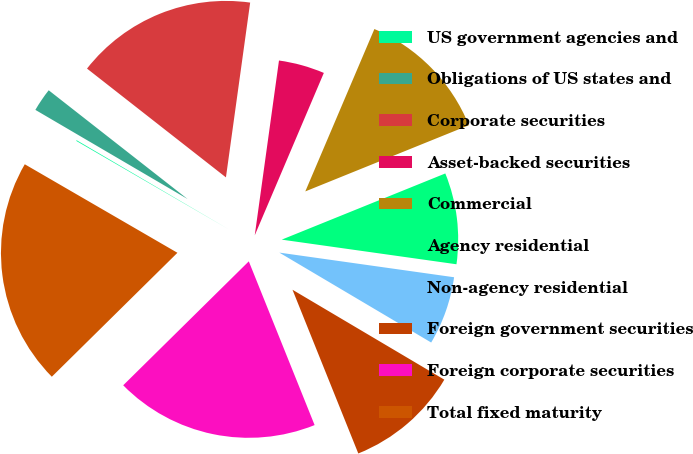<chart> <loc_0><loc_0><loc_500><loc_500><pie_chart><fcel>US government agencies and<fcel>Obligations of US states and<fcel>Corporate securities<fcel>Asset-backed securities<fcel>Commercial<fcel>Agency residential<fcel>Non-agency residential<fcel>Foreign government securities<fcel>Foreign corporate securities<fcel>Total fixed maturity<nl><fcel>0.07%<fcel>2.14%<fcel>16.62%<fcel>4.21%<fcel>12.48%<fcel>8.35%<fcel>6.28%<fcel>10.41%<fcel>18.69%<fcel>20.76%<nl></chart> 